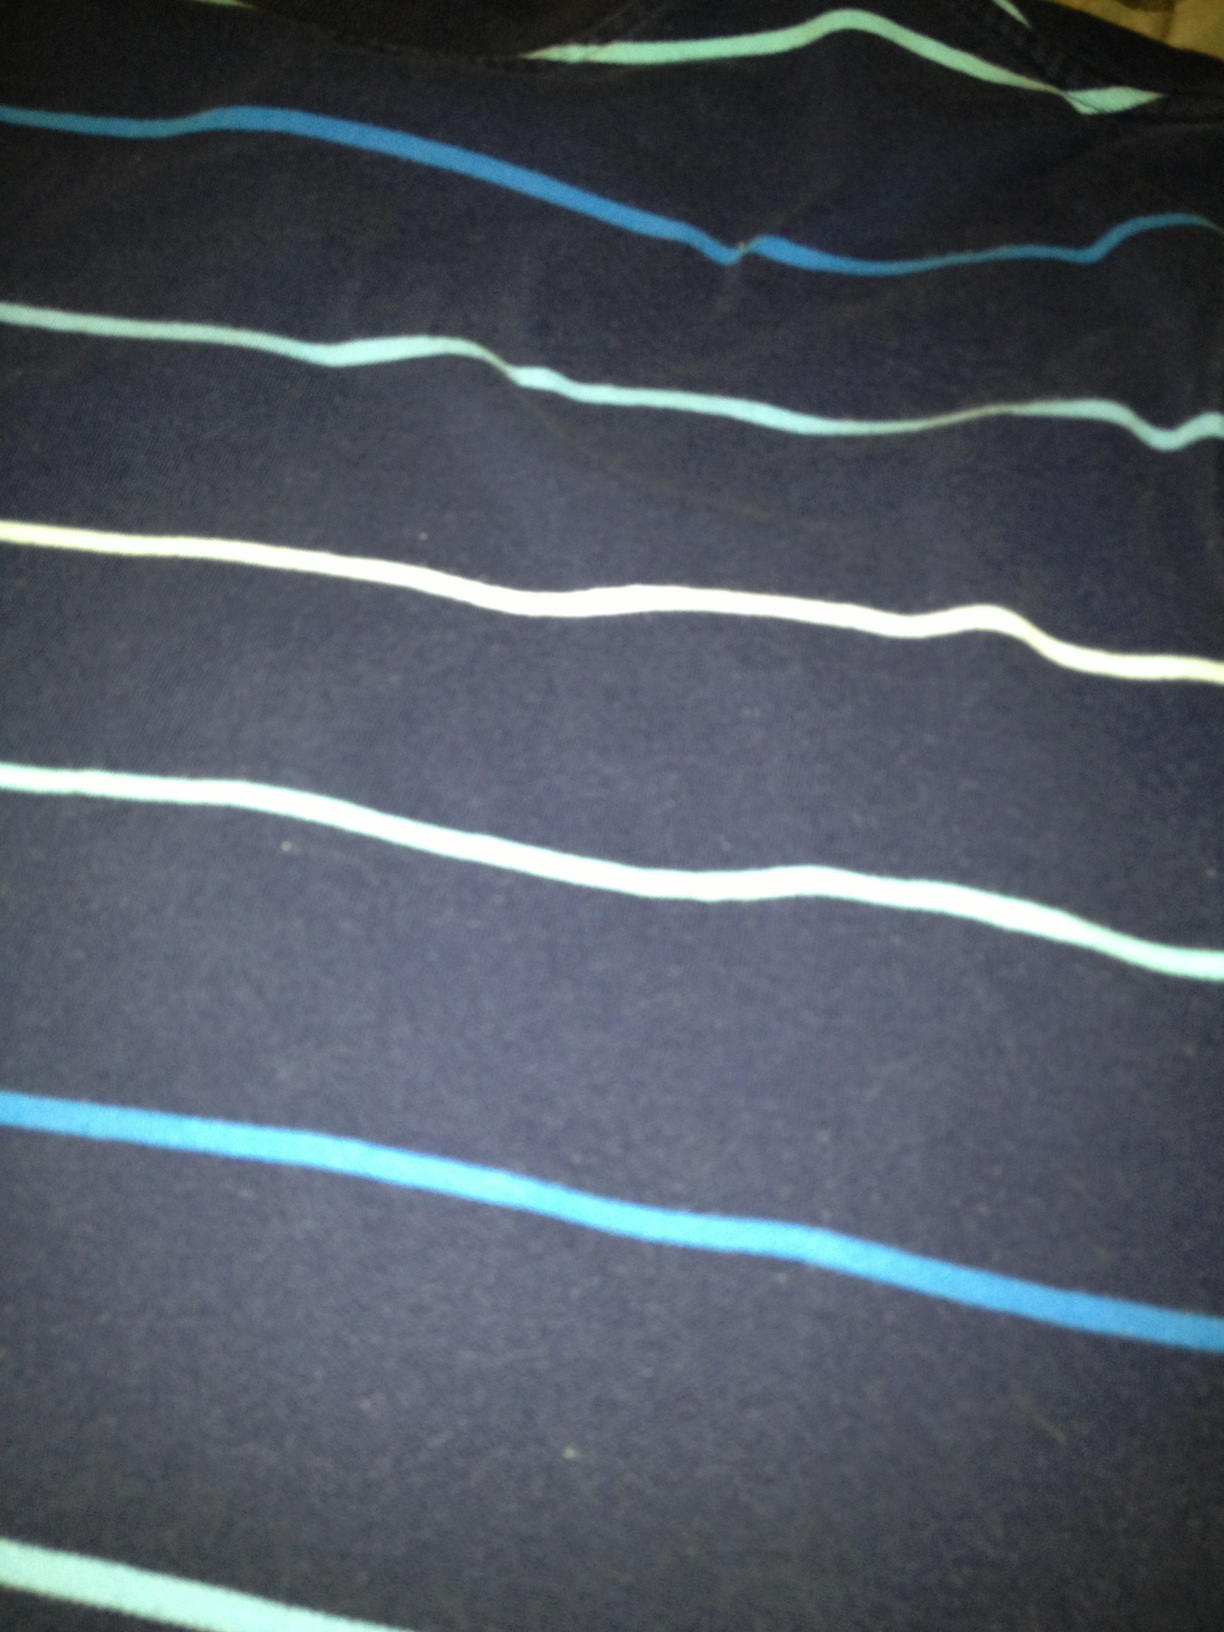What color is this shirt? The shirt predominantly features a dark grey color with blue and white horizontal stripes. The combination of colors gives it a stylish and casual appearance. 